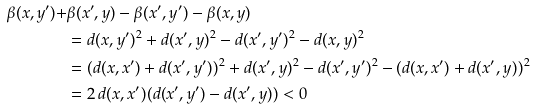<formula> <loc_0><loc_0><loc_500><loc_500>\beta ( x , y ^ { \prime } ) + & \beta ( x ^ { \prime } , y ) - \beta ( x ^ { \prime } , y ^ { \prime } ) - \beta ( x , y ) \\ & = d ( x , y ^ { \prime } ) ^ { 2 } + d ( x ^ { \prime } , y ) ^ { 2 } - d ( x ^ { \prime } , y ^ { \prime } ) ^ { 2 } - d ( x , y ) ^ { 2 } \\ & = ( d ( x , x ^ { \prime } ) + d ( x ^ { \prime } , y ^ { \prime } ) ) ^ { 2 } + d ( x ^ { \prime } , y ) ^ { 2 } - d ( x ^ { \prime } , y ^ { \prime } ) ^ { 2 } - ( d ( x , x ^ { \prime } ) + d ( x ^ { \prime } , y ) ) ^ { 2 } \\ & = 2 \, d ( x , x ^ { \prime } ) ( d ( x ^ { \prime } , y ^ { \prime } ) - d ( x ^ { \prime } , y ) ) < 0</formula> 